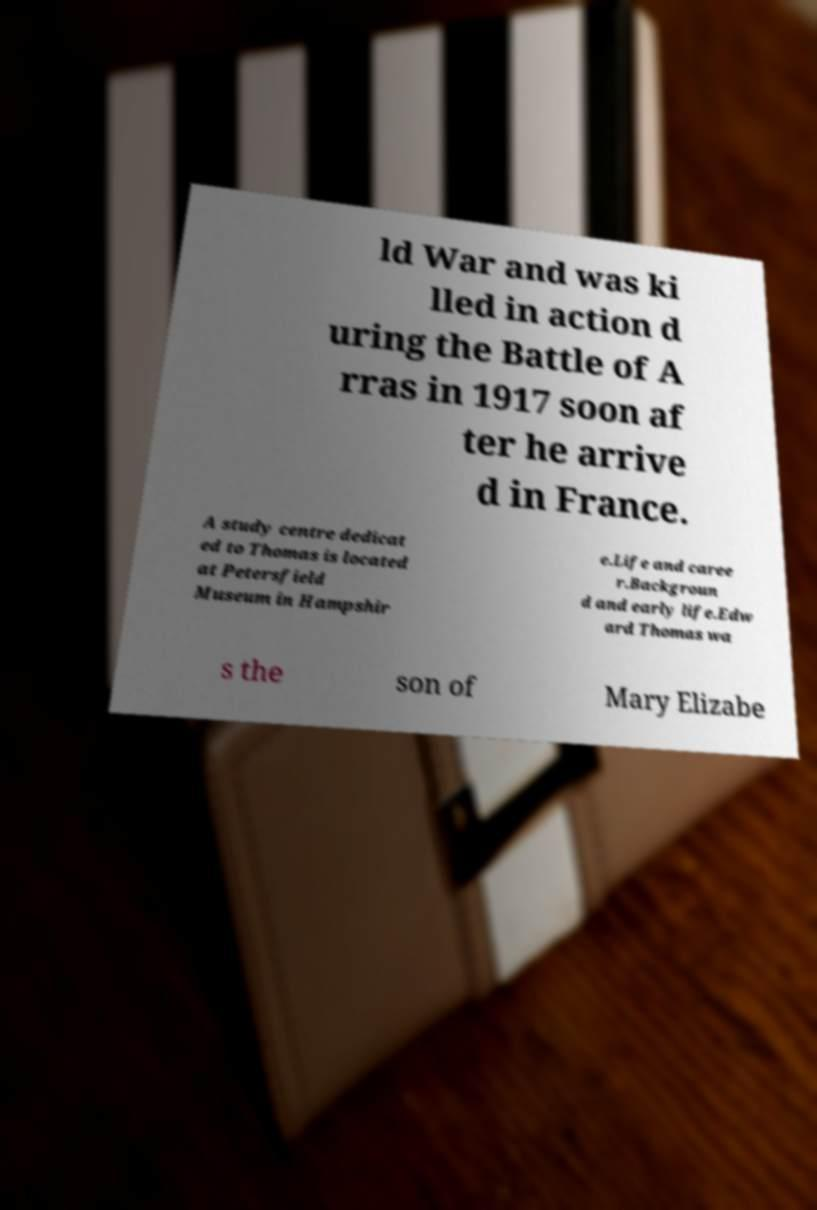For documentation purposes, I need the text within this image transcribed. Could you provide that? ld War and was ki lled in action d uring the Battle of A rras in 1917 soon af ter he arrive d in France. A study centre dedicat ed to Thomas is located at Petersfield Museum in Hampshir e.Life and caree r.Backgroun d and early life.Edw ard Thomas wa s the son of Mary Elizabe 